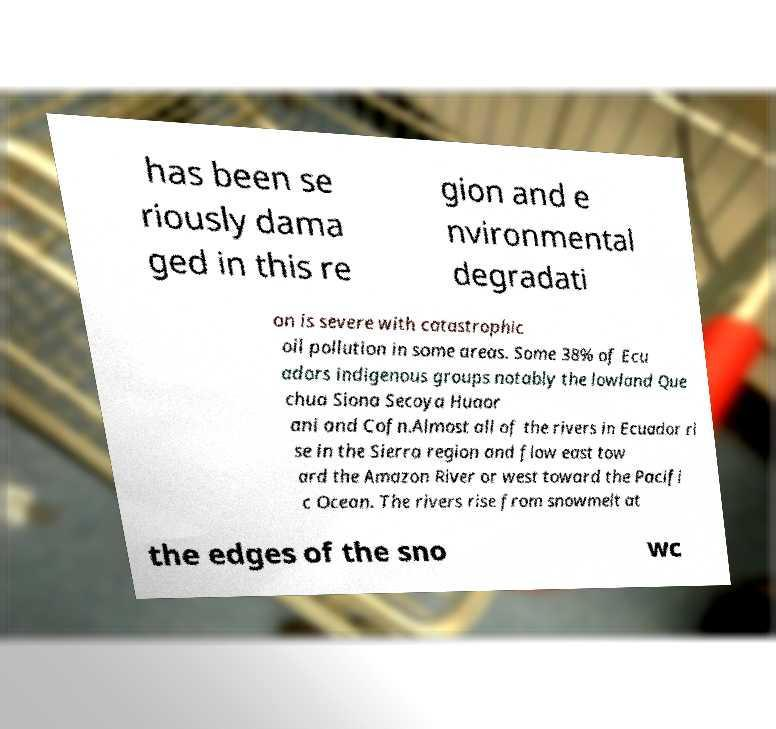Could you assist in decoding the text presented in this image and type it out clearly? has been se riously dama ged in this re gion and e nvironmental degradati on is severe with catastrophic oil pollution in some areas. Some 38% of Ecu adors indigenous groups notably the lowland Que chua Siona Secoya Huaor ani and Cofn.Almost all of the rivers in Ecuador ri se in the Sierra region and flow east tow ard the Amazon River or west toward the Pacifi c Ocean. The rivers rise from snowmelt at the edges of the sno wc 